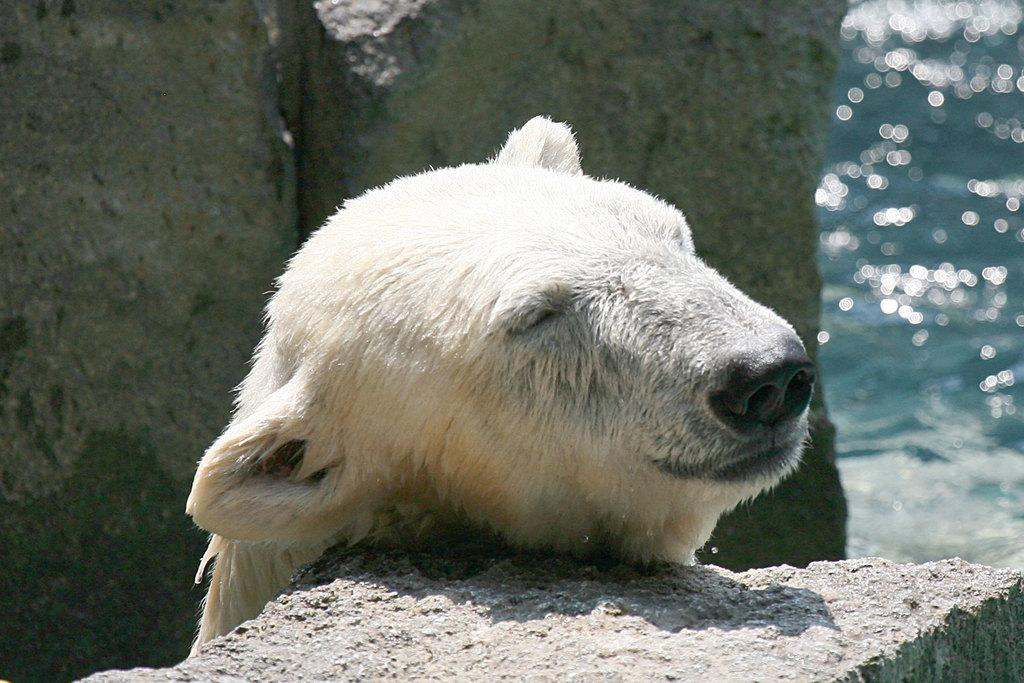What animal's face is depicted in the image? There is a polar bear's face in the image. What type of terrain can be seen in the image? There are rocks visible in the image. What type of shoes is the polar bear wearing in the image? There are no shoes present in the image, as polar bears do not wear shoes. 